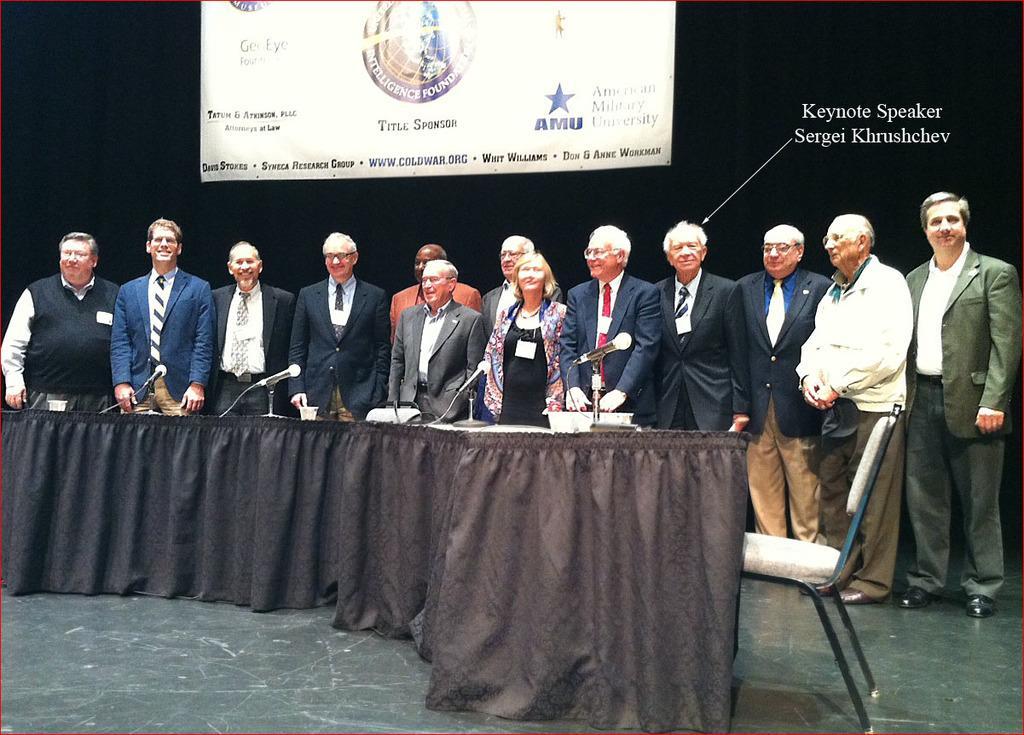In one or two sentences, can you explain what this image depicts? In this picture we can see people on the floor, here we can see a chair, mics and some objects and in the background we can see a banner and some text. 